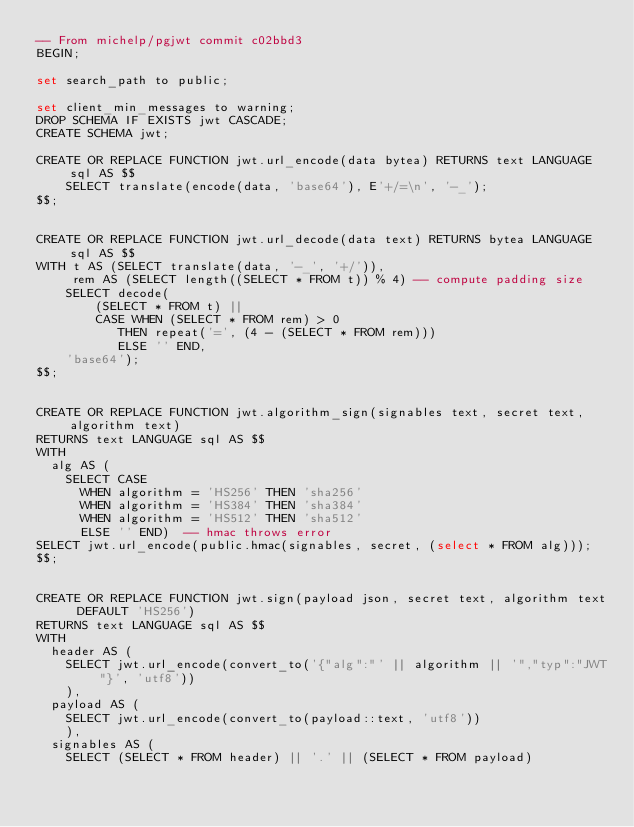<code> <loc_0><loc_0><loc_500><loc_500><_SQL_>-- From michelp/pgjwt commit c02bbd3
BEGIN;

set search_path to public;

set client_min_messages to warning;
DROP SCHEMA IF EXISTS jwt CASCADE;
CREATE SCHEMA jwt;

CREATE OR REPLACE FUNCTION jwt.url_encode(data bytea) RETURNS text LANGUAGE sql AS $$
    SELECT translate(encode(data, 'base64'), E'+/=\n', '-_');
$$;


CREATE OR REPLACE FUNCTION jwt.url_decode(data text) RETURNS bytea LANGUAGE sql AS $$
WITH t AS (SELECT translate(data, '-_', '+/')),
     rem AS (SELECT length((SELECT * FROM t)) % 4) -- compute padding size
    SELECT decode(
        (SELECT * FROM t) ||
        CASE WHEN (SELECT * FROM rem) > 0
           THEN repeat('=', (4 - (SELECT * FROM rem)))
           ELSE '' END,
    'base64');
$$;


CREATE OR REPLACE FUNCTION jwt.algorithm_sign(signables text, secret text, algorithm text)
RETURNS text LANGUAGE sql AS $$
WITH
  alg AS (
    SELECT CASE
      WHEN algorithm = 'HS256' THEN 'sha256'
      WHEN algorithm = 'HS384' THEN 'sha384'
      WHEN algorithm = 'HS512' THEN 'sha512'
      ELSE '' END)  -- hmac throws error
SELECT jwt.url_encode(public.hmac(signables, secret, (select * FROM alg)));
$$;


CREATE OR REPLACE FUNCTION jwt.sign(payload json, secret text, algorithm text DEFAULT 'HS256')
RETURNS text LANGUAGE sql AS $$
WITH
  header AS (
    SELECT jwt.url_encode(convert_to('{"alg":"' || algorithm || '","typ":"JWT"}', 'utf8'))
    ),
  payload AS (
    SELECT jwt.url_encode(convert_to(payload::text, 'utf8'))
    ),
  signables AS (
    SELECT (SELECT * FROM header) || '.' || (SELECT * FROM payload)</code> 